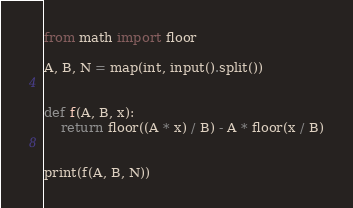<code> <loc_0><loc_0><loc_500><loc_500><_Python_>from math import floor

A, B, N = map(int, input().split())


def f(A, B, x):
    return floor((A * x) / B) - A * floor(x / B)


print(f(A, B, N))
</code> 